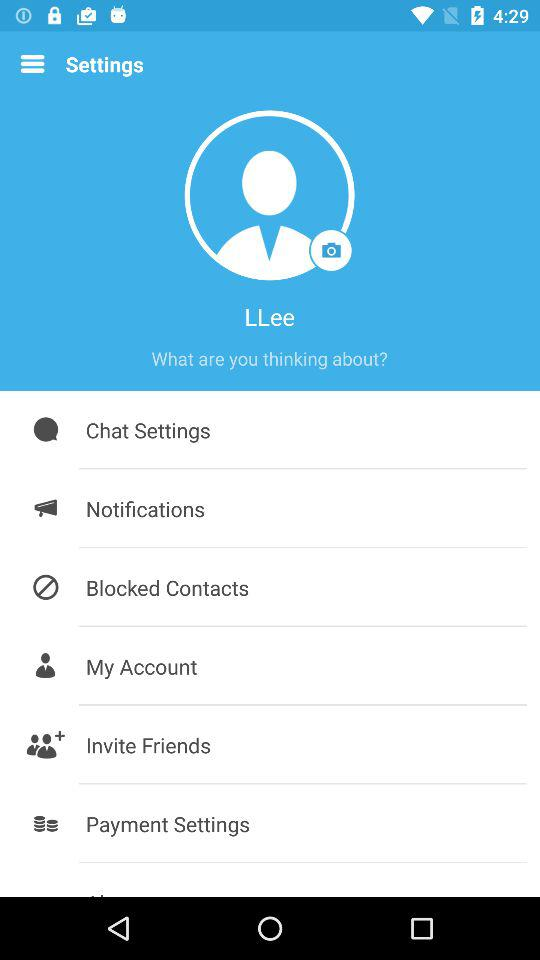What is the username? The username is "LLee". 